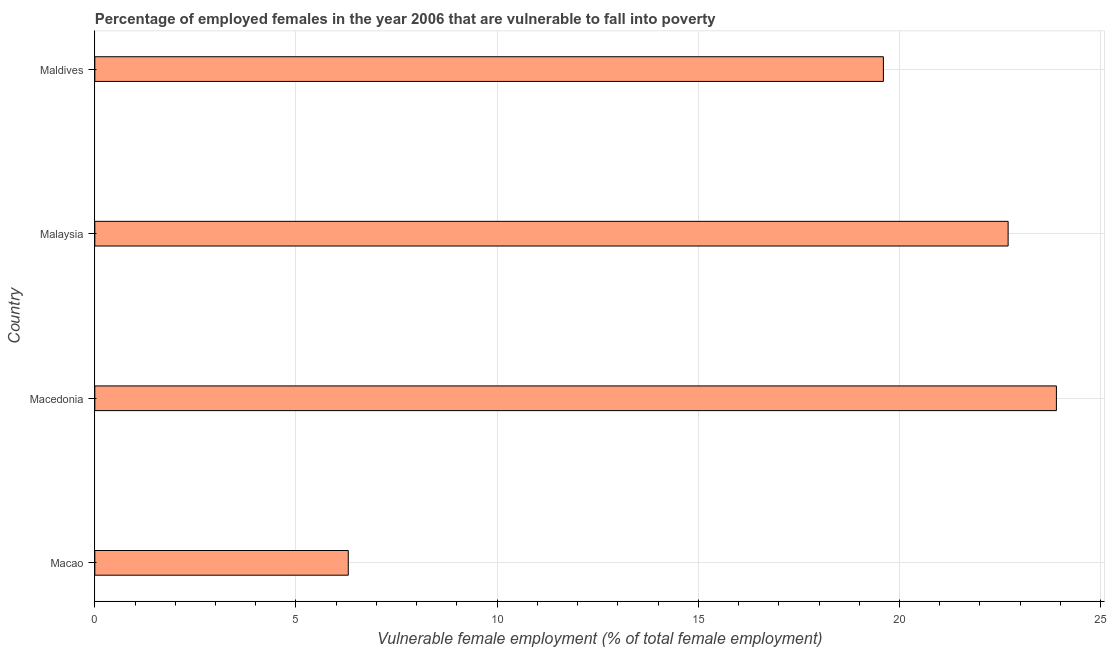What is the title of the graph?
Your answer should be very brief. Percentage of employed females in the year 2006 that are vulnerable to fall into poverty. What is the label or title of the X-axis?
Your response must be concise. Vulnerable female employment (% of total female employment). What is the percentage of employed females who are vulnerable to fall into poverty in Malaysia?
Your response must be concise. 22.7. Across all countries, what is the maximum percentage of employed females who are vulnerable to fall into poverty?
Your answer should be compact. 23.9. Across all countries, what is the minimum percentage of employed females who are vulnerable to fall into poverty?
Provide a short and direct response. 6.3. In which country was the percentage of employed females who are vulnerable to fall into poverty maximum?
Give a very brief answer. Macedonia. In which country was the percentage of employed females who are vulnerable to fall into poverty minimum?
Provide a succinct answer. Macao. What is the sum of the percentage of employed females who are vulnerable to fall into poverty?
Your answer should be compact. 72.5. What is the difference between the percentage of employed females who are vulnerable to fall into poverty in Macedonia and Maldives?
Keep it short and to the point. 4.3. What is the average percentage of employed females who are vulnerable to fall into poverty per country?
Your answer should be compact. 18.12. What is the median percentage of employed females who are vulnerable to fall into poverty?
Make the answer very short. 21.15. What is the ratio of the percentage of employed females who are vulnerable to fall into poverty in Malaysia to that in Maldives?
Offer a very short reply. 1.16. Is the sum of the percentage of employed females who are vulnerable to fall into poverty in Macedonia and Maldives greater than the maximum percentage of employed females who are vulnerable to fall into poverty across all countries?
Your answer should be very brief. Yes. What is the difference between the highest and the lowest percentage of employed females who are vulnerable to fall into poverty?
Your answer should be compact. 17.6. Are all the bars in the graph horizontal?
Your answer should be compact. Yes. How many countries are there in the graph?
Keep it short and to the point. 4. Are the values on the major ticks of X-axis written in scientific E-notation?
Your response must be concise. No. What is the Vulnerable female employment (% of total female employment) in Macao?
Provide a succinct answer. 6.3. What is the Vulnerable female employment (% of total female employment) of Macedonia?
Keep it short and to the point. 23.9. What is the Vulnerable female employment (% of total female employment) of Malaysia?
Provide a short and direct response. 22.7. What is the Vulnerable female employment (% of total female employment) of Maldives?
Your response must be concise. 19.6. What is the difference between the Vulnerable female employment (% of total female employment) in Macao and Macedonia?
Your answer should be very brief. -17.6. What is the difference between the Vulnerable female employment (% of total female employment) in Macao and Malaysia?
Ensure brevity in your answer.  -16.4. What is the difference between the Vulnerable female employment (% of total female employment) in Macedonia and Malaysia?
Give a very brief answer. 1.2. What is the difference between the Vulnerable female employment (% of total female employment) in Macedonia and Maldives?
Make the answer very short. 4.3. What is the difference between the Vulnerable female employment (% of total female employment) in Malaysia and Maldives?
Provide a succinct answer. 3.1. What is the ratio of the Vulnerable female employment (% of total female employment) in Macao to that in Macedonia?
Your answer should be compact. 0.26. What is the ratio of the Vulnerable female employment (% of total female employment) in Macao to that in Malaysia?
Ensure brevity in your answer.  0.28. What is the ratio of the Vulnerable female employment (% of total female employment) in Macao to that in Maldives?
Make the answer very short. 0.32. What is the ratio of the Vulnerable female employment (% of total female employment) in Macedonia to that in Malaysia?
Ensure brevity in your answer.  1.05. What is the ratio of the Vulnerable female employment (% of total female employment) in Macedonia to that in Maldives?
Make the answer very short. 1.22. What is the ratio of the Vulnerable female employment (% of total female employment) in Malaysia to that in Maldives?
Give a very brief answer. 1.16. 